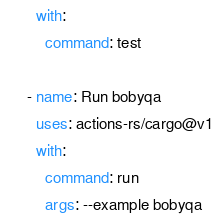Convert code to text. <code><loc_0><loc_0><loc_500><loc_500><_YAML_>        with:
          command: test

      - name: Run bobyqa
        uses: actions-rs/cargo@v1
        with:
          command: run
          args: --example bobyqa
</code> 